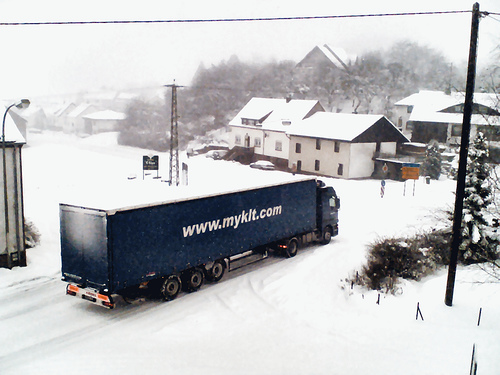What kind of vehicle is depicted in this snowy scene? The image shows a large cargo truck, typically used for transporting goods over long distances. Its trailer is adorned with a commercial website, indicating that it likely belongs to a delivery or logistics company. 